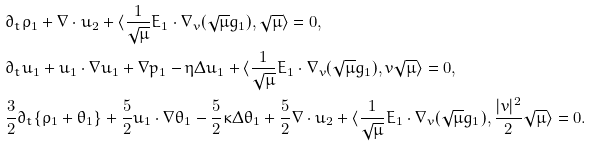<formula> <loc_0><loc_0><loc_500><loc_500>& \partial _ { t } \rho _ { 1 } + \nabla \cdot u _ { 2 } + \langle \frac { 1 } { \sqrt { \mu } } E _ { 1 } \cdot \nabla _ { v } ( \sqrt { \mu } g _ { 1 } ) , \sqrt { \mu } \rangle = 0 , \\ & \partial _ { t } u _ { 1 } + u _ { 1 } \cdot \nabla u _ { 1 } + \nabla p _ { 1 } - \eta \Delta u _ { 1 } + \langle \frac { 1 } { \sqrt { \mu } } E _ { 1 } \cdot \nabla _ { v } ( \sqrt { \mu } g _ { 1 } ) , v \sqrt { \mu } \rangle = 0 , \\ & \frac { 3 } { 2 } \partial _ { t } \{ \rho _ { 1 } + \theta _ { 1 } \} + \frac { 5 } { 2 } u _ { 1 } \cdot \nabla \theta _ { 1 } - \frac { 5 } { 2 } \kappa \Delta \theta _ { 1 } + \frac { 5 } { 2 } \nabla \cdot u _ { 2 } + \langle \frac { 1 } { \sqrt { \mu } } E _ { 1 } \cdot \nabla _ { v } ( \sqrt { \mu } g _ { 1 } ) , \frac { | v | ^ { 2 } } { 2 } \sqrt { \mu } \rangle = 0 . \\</formula> 